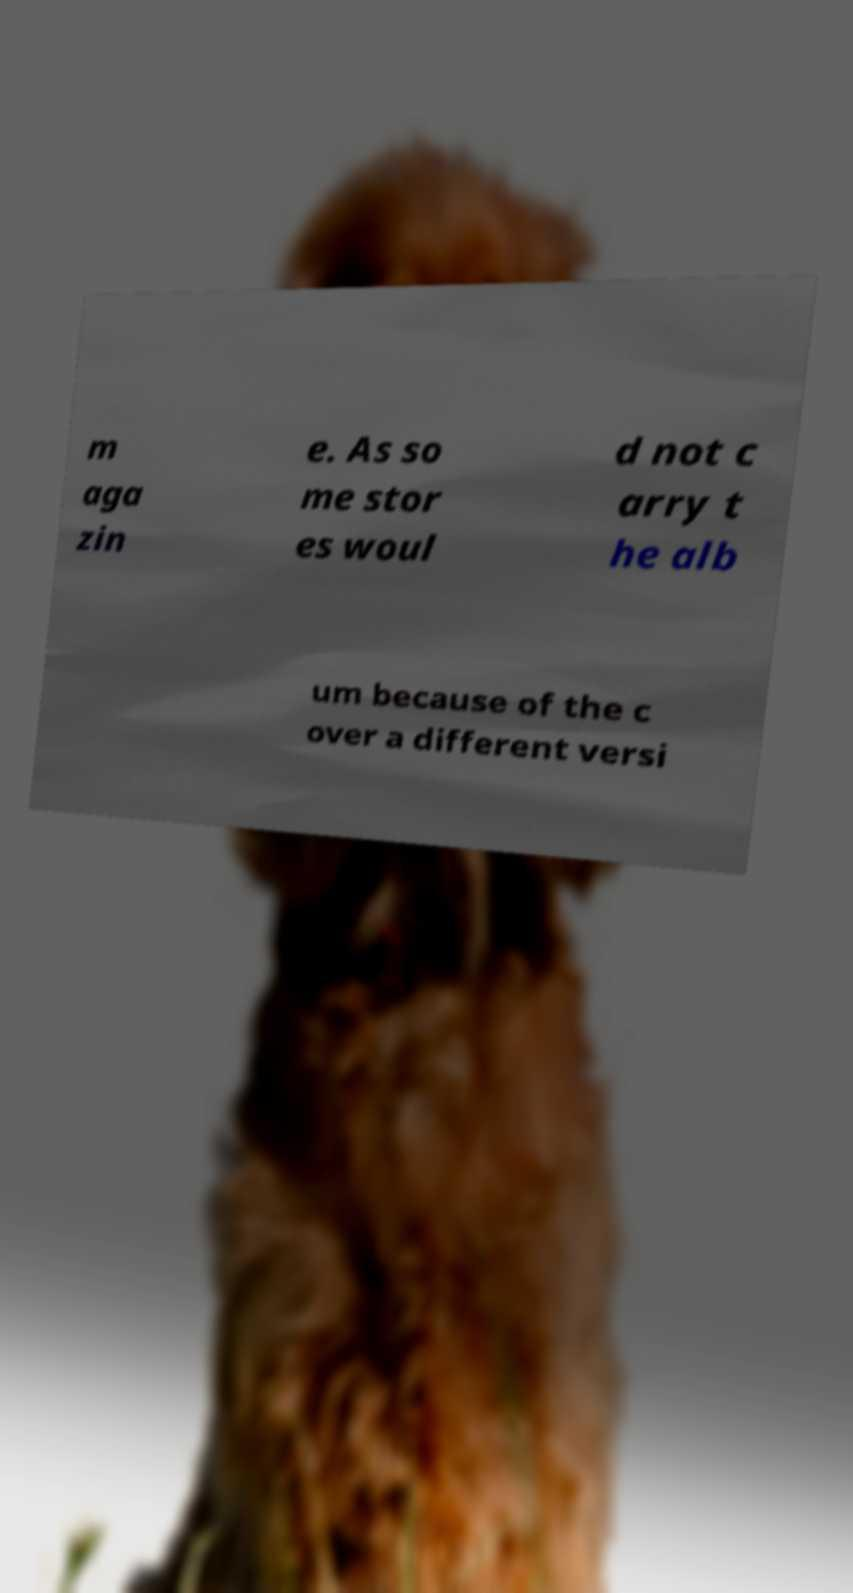Can you accurately transcribe the text from the provided image for me? m aga zin e. As so me stor es woul d not c arry t he alb um because of the c over a different versi 